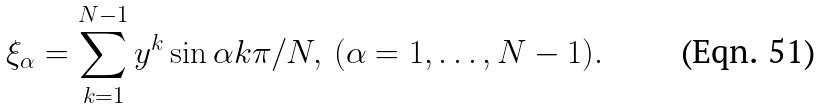<formula> <loc_0><loc_0><loc_500><loc_500>\xi _ { \alpha } = \sum _ { k = 1 } ^ { N - 1 } y ^ { k } \sin \alpha k \pi / N , \, ( \alpha = 1 , \dots , N - 1 ) .</formula> 